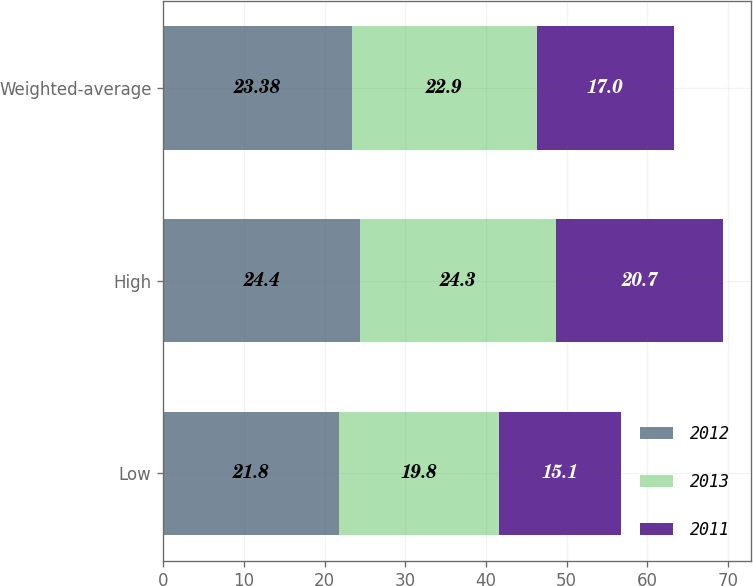<chart> <loc_0><loc_0><loc_500><loc_500><stacked_bar_chart><ecel><fcel>Low<fcel>High<fcel>Weighted-average<nl><fcel>2012<fcel>21.8<fcel>24.4<fcel>23.38<nl><fcel>2013<fcel>19.8<fcel>24.3<fcel>22.9<nl><fcel>2011<fcel>15.1<fcel>20.7<fcel>17<nl></chart> 